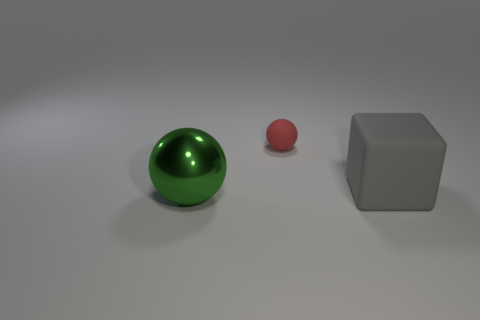Is there anything else that has the same size as the red rubber thing?
Your response must be concise. No. Is the shape of the green metal thing the same as the tiny object?
Your answer should be very brief. Yes. The gray object has what size?
Ensure brevity in your answer.  Large. Is the size of the gray rubber block the same as the green thing?
Give a very brief answer. Yes. What color is the thing that is both in front of the red rubber sphere and to the left of the block?
Offer a terse response. Green. How many gray things are made of the same material as the small red ball?
Offer a very short reply. 1. What number of spheres are there?
Provide a short and direct response. 2. Is the size of the green sphere the same as the sphere that is behind the green thing?
Your answer should be very brief. No. There is a sphere in front of the big object right of the tiny red sphere; what is its material?
Offer a very short reply. Metal. There is a ball that is to the left of the sphere that is to the right of the ball in front of the big gray matte object; what is its size?
Your response must be concise. Large. 